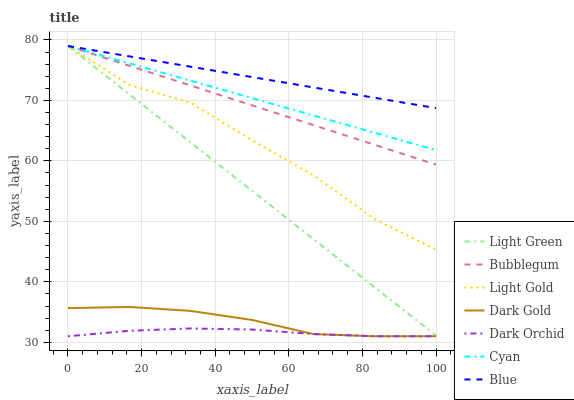Does Dark Orchid have the minimum area under the curve?
Answer yes or no. Yes. Does Blue have the maximum area under the curve?
Answer yes or no. Yes. Does Dark Gold have the minimum area under the curve?
Answer yes or no. No. Does Dark Gold have the maximum area under the curve?
Answer yes or no. No. Is Light Green the smoothest?
Answer yes or no. Yes. Is Light Gold the roughest?
Answer yes or no. Yes. Is Dark Gold the smoothest?
Answer yes or no. No. Is Dark Gold the roughest?
Answer yes or no. No. Does Dark Gold have the lowest value?
Answer yes or no. Yes. Does Bubblegum have the lowest value?
Answer yes or no. No. Does Light Gold have the highest value?
Answer yes or no. Yes. Does Dark Gold have the highest value?
Answer yes or no. No. Is Dark Orchid less than Light Green?
Answer yes or no. Yes. Is Cyan greater than Dark Orchid?
Answer yes or no. Yes. Does Light Green intersect Bubblegum?
Answer yes or no. Yes. Is Light Green less than Bubblegum?
Answer yes or no. No. Is Light Green greater than Bubblegum?
Answer yes or no. No. Does Dark Orchid intersect Light Green?
Answer yes or no. No. 